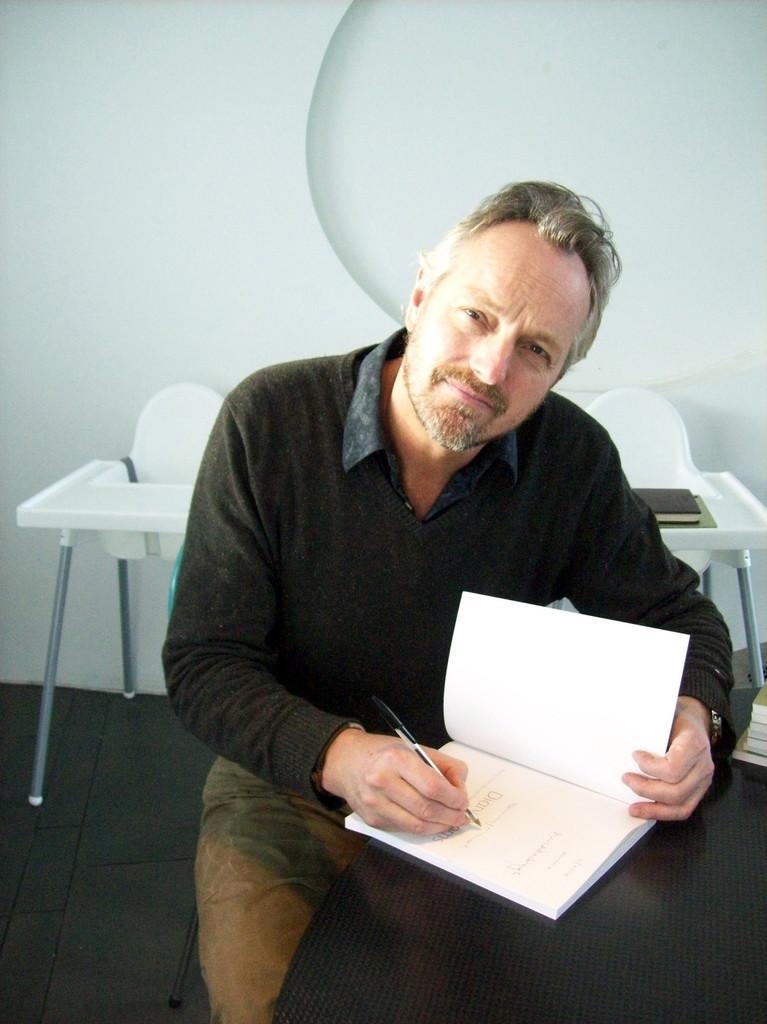Could you give a brief overview of what you see in this image? In this picture we have a man sitting in the chair and writing with the pen in the book in the table and in the back ground we have another table ,and wall. 